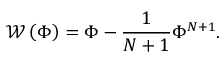Convert formula to latex. <formula><loc_0><loc_0><loc_500><loc_500>{ \mathcal { W } } \left ( \Phi \right ) = \Phi - \frac { 1 } { N + 1 } \Phi ^ { N + 1 } .</formula> 